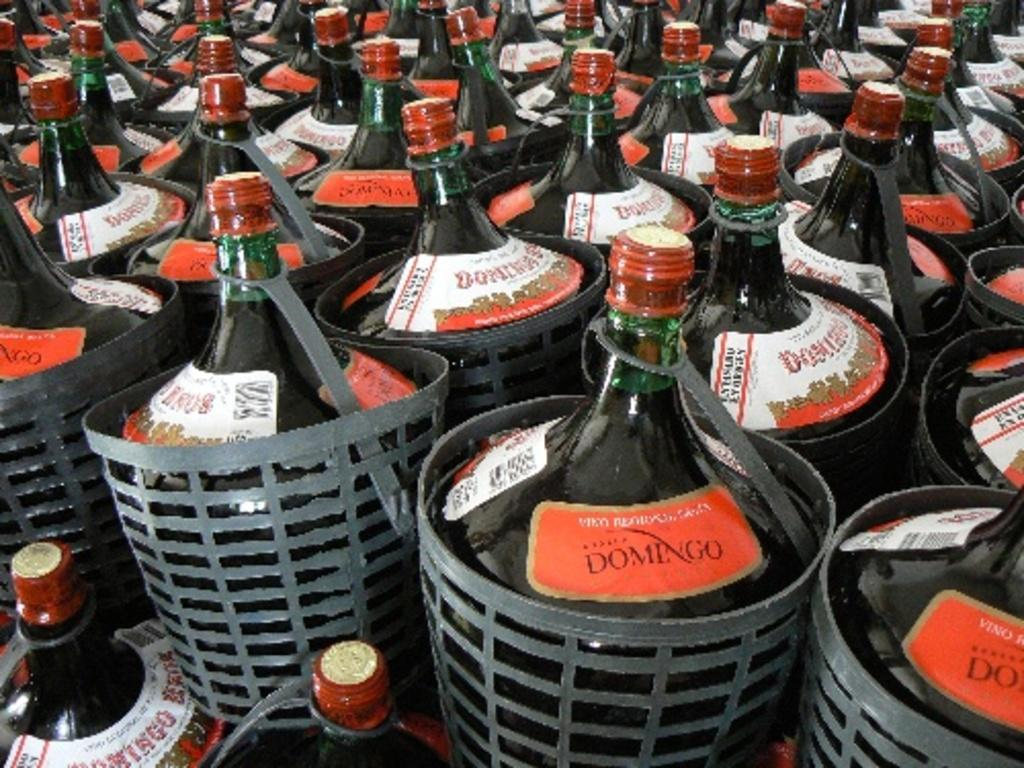<image>
Create a compact narrative representing the image presented. The bottles are filled with a drink called Domingo. 